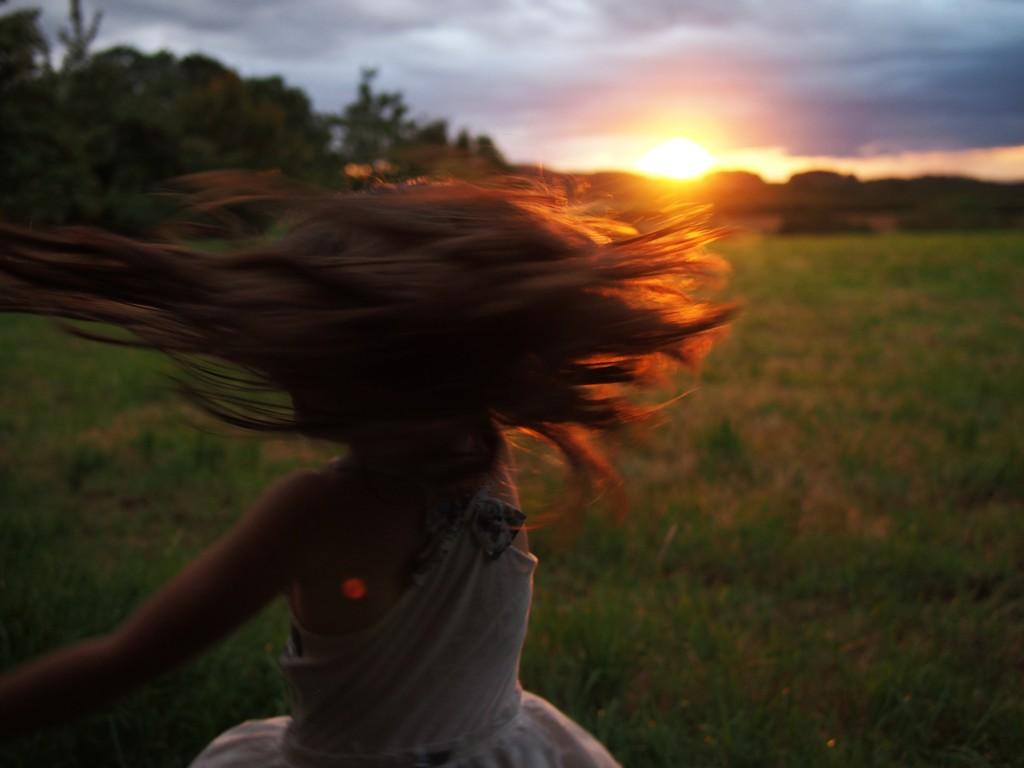Who is present in the image? There is a woman in the image. What type of natural environment is visible in the image? There is grass visible in the image. How would you describe the background of the image? The background of the image is blurry. What can be seen in the distance in the image? There are trees and the sky visible in the background of the image. What is the condition of the sky in the image? Clouds are present in the sky. How many babies are crawling on the grass in the image? There are no babies present in the image; it features a woman and a blurry background with trees and clouds. 